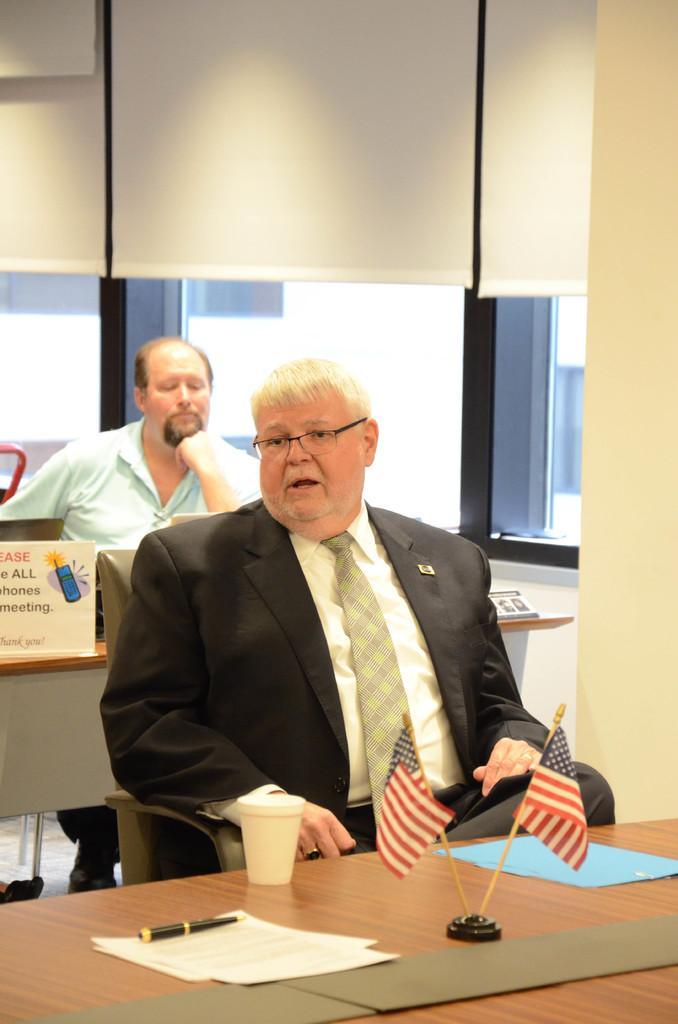In one or two sentences, can you explain what this image depicts? There is a room. The two persons are sitting on a chair. There is a table. There is a glass,flag,pen on a table. In the center we have a person. He is wearing a spectacle and tie. We can see in background wall and cupboard. 